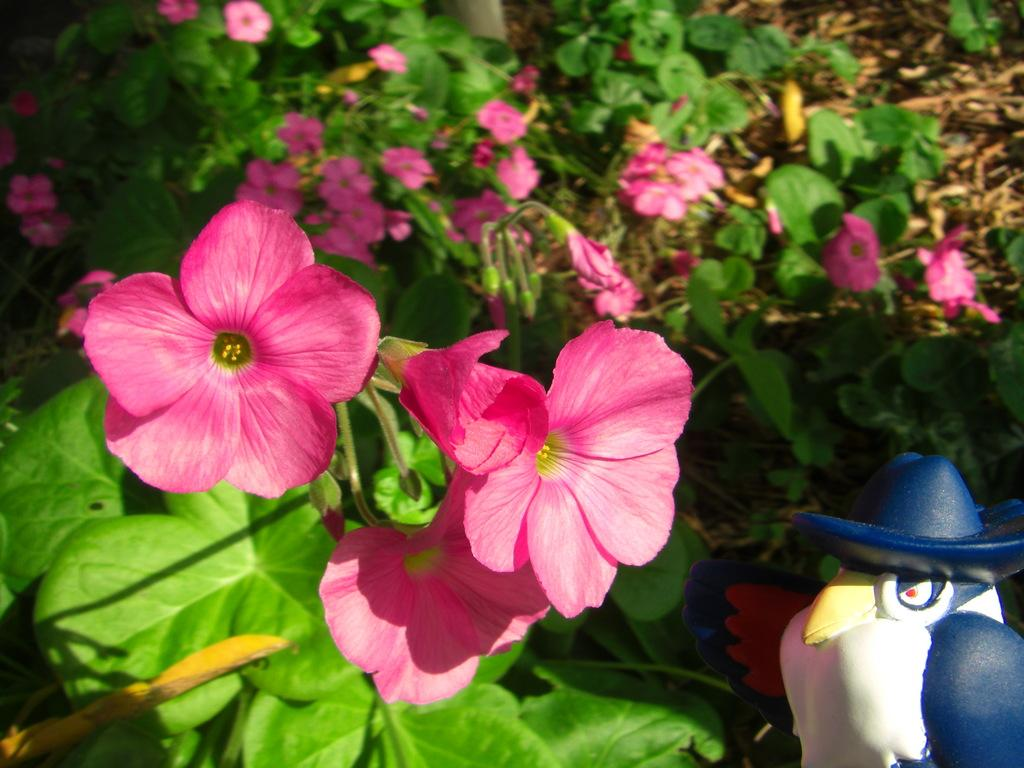What type of flowers can be seen in the image? There are pink color flowers in the image. What else can be seen in the image besides the flowers? There are leaves in the image. Where is the sculpture located in the image? There is a blue and white color sculpture in the bottom right side of the image. How many friends are present in the image? There are no friends depicted in the image; it features flowers, leaves, and a sculpture. What time is it according to the hour hand in the image? There is no clock or hour hand present in the image. 